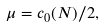<formula> <loc_0><loc_0><loc_500><loc_500>\mu = c _ { 0 } ( N ) / 2 ,</formula> 